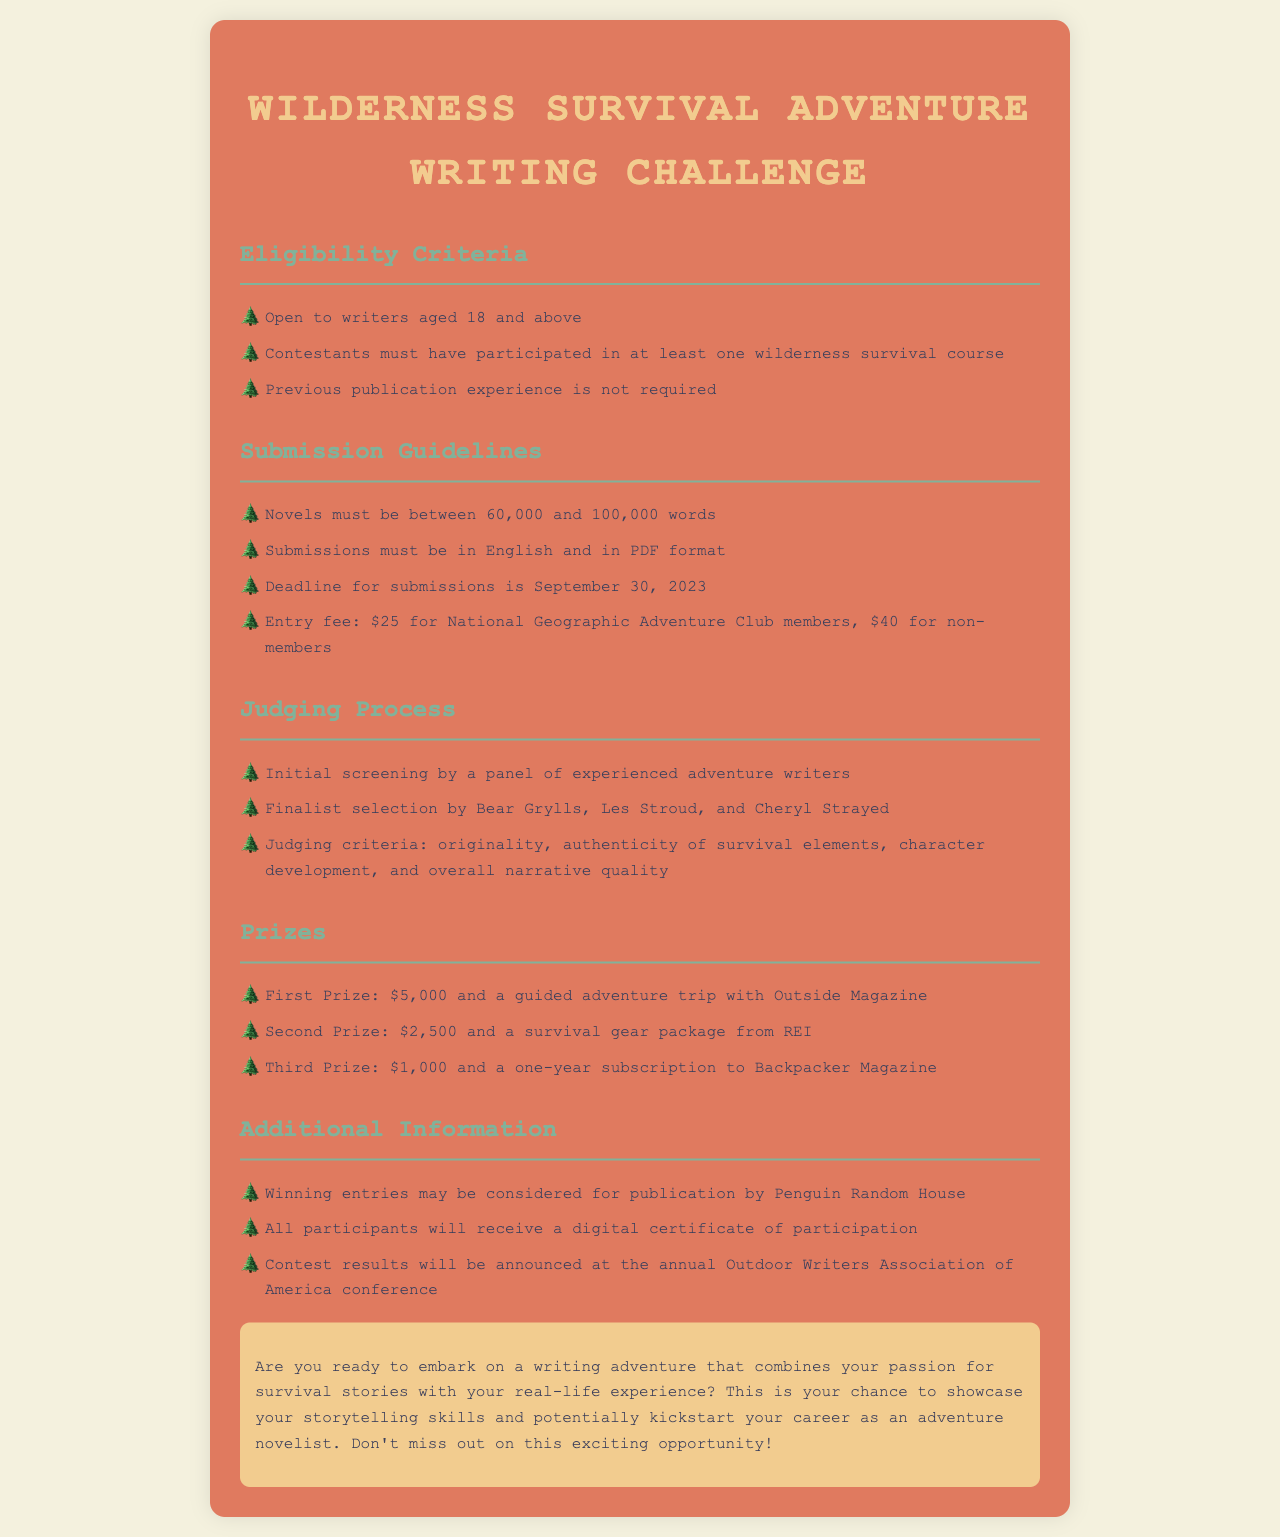What is the minimum age for contestants? Contestants must be aged 18 and above to qualify, as stated in the eligibility criteria.
Answer: 18 What is the maximum word count for submissions? The submissions for the contest must be between 60,000 and 100,000 words, according to the submission guidelines.
Answer: 100,000 What is the deadline for submissions? The deadline for submitting entries is clearly specified in the document as September 30, 2023.
Answer: September 30, 2023 Who selects the finalists in the judging process? The finalists are selected by notable adventure writers, specifically named in the document as Bear Grylls, Les Stroud, and Cheryl Strayed.
Answer: Bear Grylls, Les Stroud, and Cheryl Strayed What is the entry fee for non-members? The document outlines that non-members need to pay a specific fee to participate, which is clearly detailed.
Answer: $40 What is the first prize for the contest? The document outlines the prize structure, specifying the rewards for winners, with the first prize being mentioned.
Answer: $5,000 and a guided adventure trip with Outside Magazine What is required from contestants in terms of prior experience? One specific requirement in the eligibility criteria is that contestants must have taken part in at least one wilderness survival course.
Answer: One wilderness survival course What type of certificate will all participants receive? The document states that all participants will receive a digital certificate for their involvement in the contest.
Answer: Digital certificate of participation What element is NOT required for eligibility? The eligibility criteria also clarify what is not a prerequisite for entering the contest, specifically prior publication experience.
Answer: Previous publication experience 